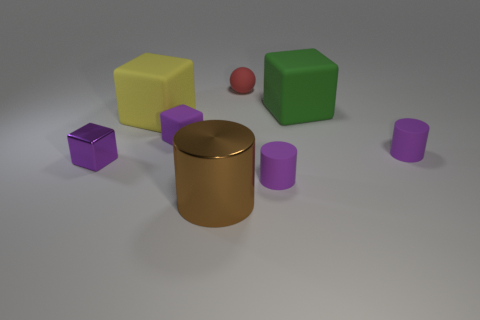There is a small cylinder on the left side of the big thing that is right of the big metal thing; what is its color?
Give a very brief answer. Purple. There is a cube that is made of the same material as the brown cylinder; what is its color?
Offer a very short reply. Purple. How many large blocks have the same color as the large metal cylinder?
Your answer should be very brief. 0. How many things are either big matte objects or rubber cylinders?
Offer a terse response. 4. There is a purple metal thing that is the same size as the purple rubber block; what is its shape?
Provide a short and direct response. Cube. How many purple objects are on the right side of the tiny purple metal object and left of the brown shiny object?
Give a very brief answer. 1. What is the small purple cube behind the shiny block made of?
Provide a short and direct response. Rubber. What size is the yellow thing that is the same material as the red ball?
Your answer should be compact. Large. Is the size of the purple thing that is on the right side of the green cube the same as the matte thing that is behind the big green rubber object?
Ensure brevity in your answer.  Yes. There is a cylinder that is the same size as the yellow block; what material is it?
Your response must be concise. Metal. 